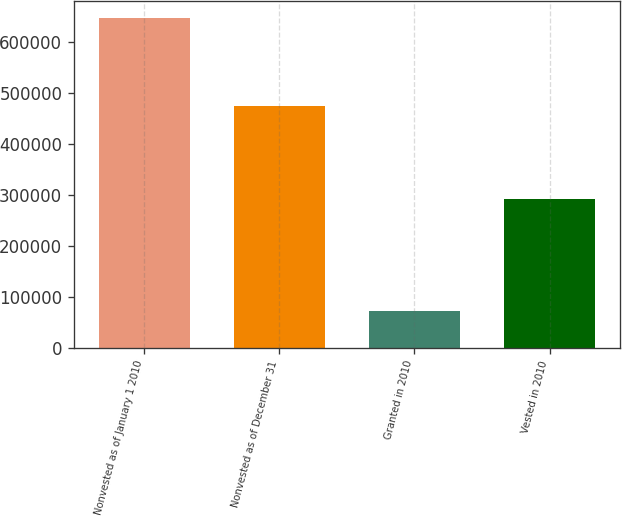Convert chart. <chart><loc_0><loc_0><loc_500><loc_500><bar_chart><fcel>Nonvested as of January 1 2010<fcel>Nonvested as of December 31<fcel>Granted in 2010<fcel>Vested in 2010<nl><fcel>648293<fcel>475914<fcel>71752<fcel>292152<nl></chart> 